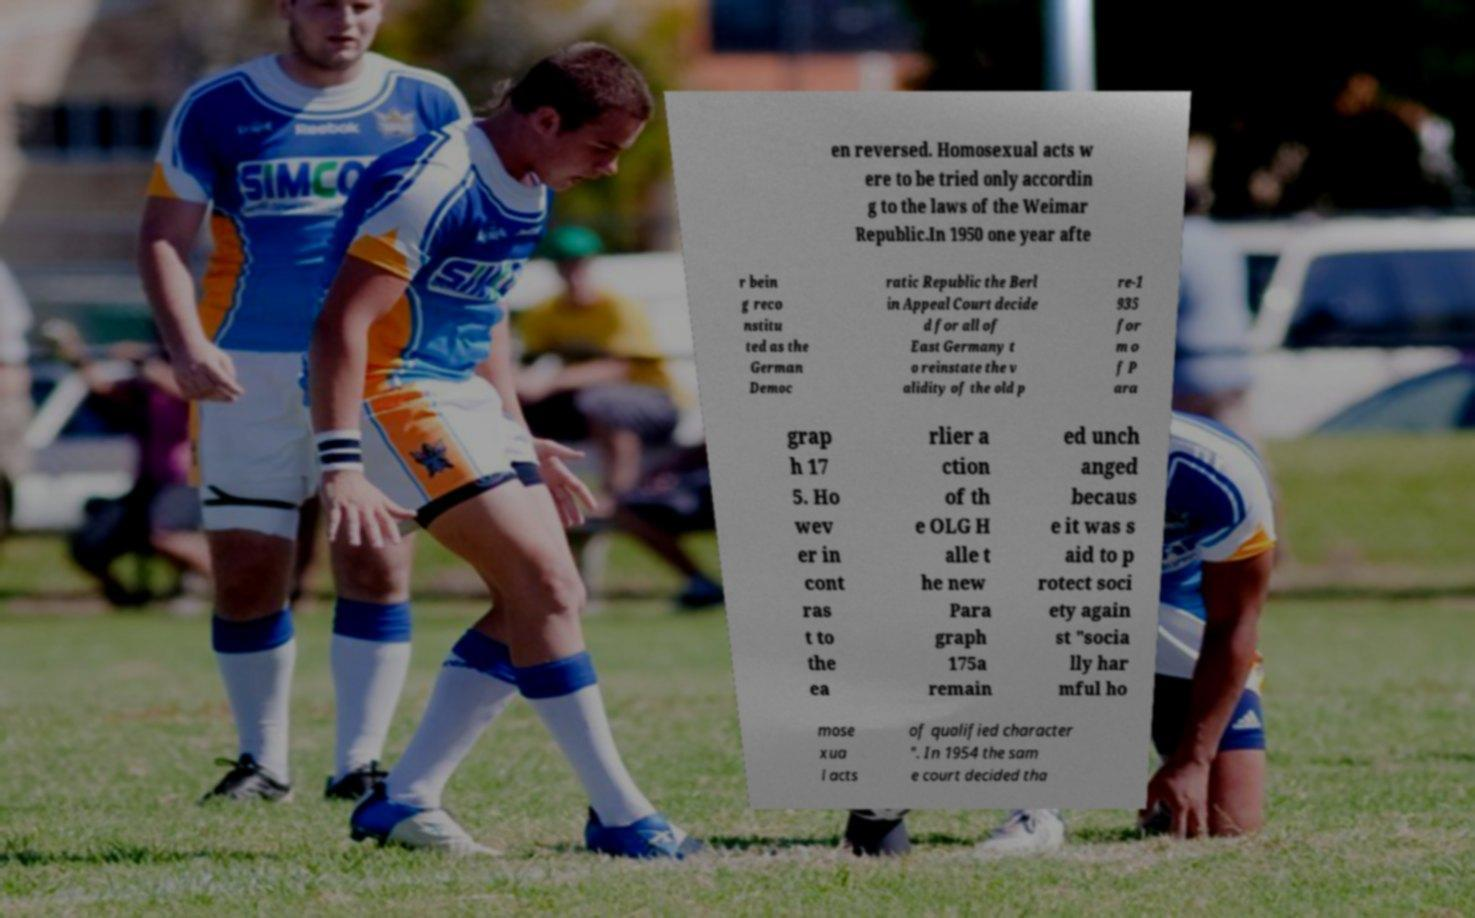I need the written content from this picture converted into text. Can you do that? en reversed. Homosexual acts w ere to be tried only accordin g to the laws of the Weimar Republic.In 1950 one year afte r bein g reco nstitu ted as the German Democ ratic Republic the Berl in Appeal Court decide d for all of East Germany t o reinstate the v alidity of the old p re-1 935 for m o f P ara grap h 17 5. Ho wev er in cont ras t to the ea rlier a ction of th e OLG H alle t he new Para graph 175a remain ed unch anged becaus e it was s aid to p rotect soci ety again st "socia lly har mful ho mose xua l acts of qualified character ". In 1954 the sam e court decided tha 